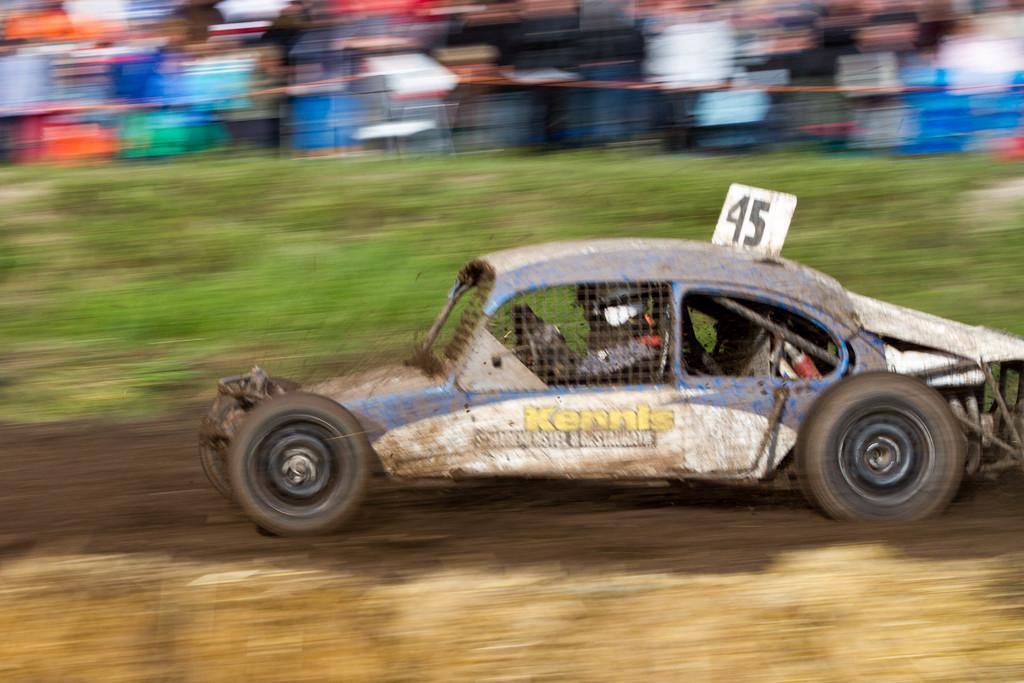Could you give a brief overview of what you see in this image? In the foreground of this image, there is a car moving on the ground. In the background, the image is blurred. 